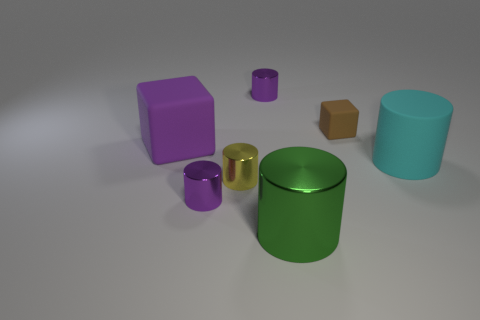Are there any large blocks that have the same color as the tiny matte thing?
Keep it short and to the point. No. What color is the matte block that is the same size as the cyan cylinder?
Your answer should be compact. Purple. There is a small shiny cylinder behind the cyan rubber cylinder; does it have the same color as the rubber cylinder?
Give a very brief answer. No. Is there a large yellow thing that has the same material as the cyan cylinder?
Give a very brief answer. No. Are there fewer cylinders that are right of the yellow metal cylinder than large gray objects?
Offer a terse response. No. Does the rubber block on the right side of the green metallic cylinder have the same size as the big cyan rubber object?
Give a very brief answer. No. What number of other green objects have the same shape as the tiny matte thing?
Keep it short and to the point. 0. There is a brown thing that is made of the same material as the large cyan cylinder; what is its size?
Offer a very short reply. Small. Is the number of green things in front of the yellow cylinder the same as the number of rubber cylinders?
Keep it short and to the point. Yes. Does the small rubber thing have the same color as the large matte cylinder?
Offer a very short reply. No. 